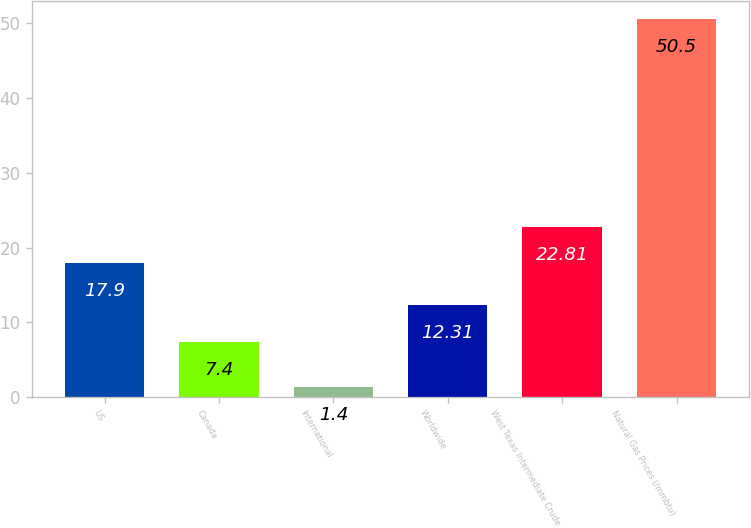Convert chart. <chart><loc_0><loc_0><loc_500><loc_500><bar_chart><fcel>US<fcel>Canada<fcel>International<fcel>Worldwide<fcel>West Texas Intermediate Crude<fcel>Natural Gas Prices (/mmbtu)<nl><fcel>17.9<fcel>7.4<fcel>1.4<fcel>12.31<fcel>22.81<fcel>50.5<nl></chart> 